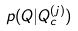<formula> <loc_0><loc_0><loc_500><loc_500>p ( Q | Q _ { c } ^ { ( j ) } )</formula> 